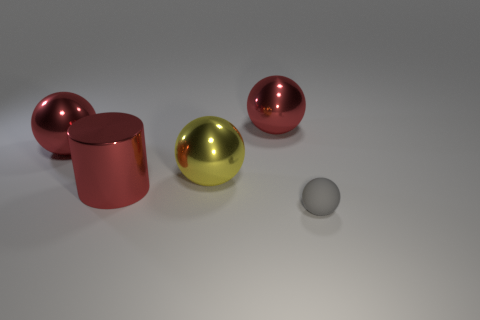Add 3 tiny matte objects. How many objects exist? 8 Subtract all cylinders. How many objects are left? 4 Add 1 tiny cyan cubes. How many tiny cyan cubes exist? 1 Subtract 0 cyan cylinders. How many objects are left? 5 Subtract all big shiny spheres. Subtract all yellow metal balls. How many objects are left? 1 Add 1 tiny spheres. How many tiny spheres are left? 2 